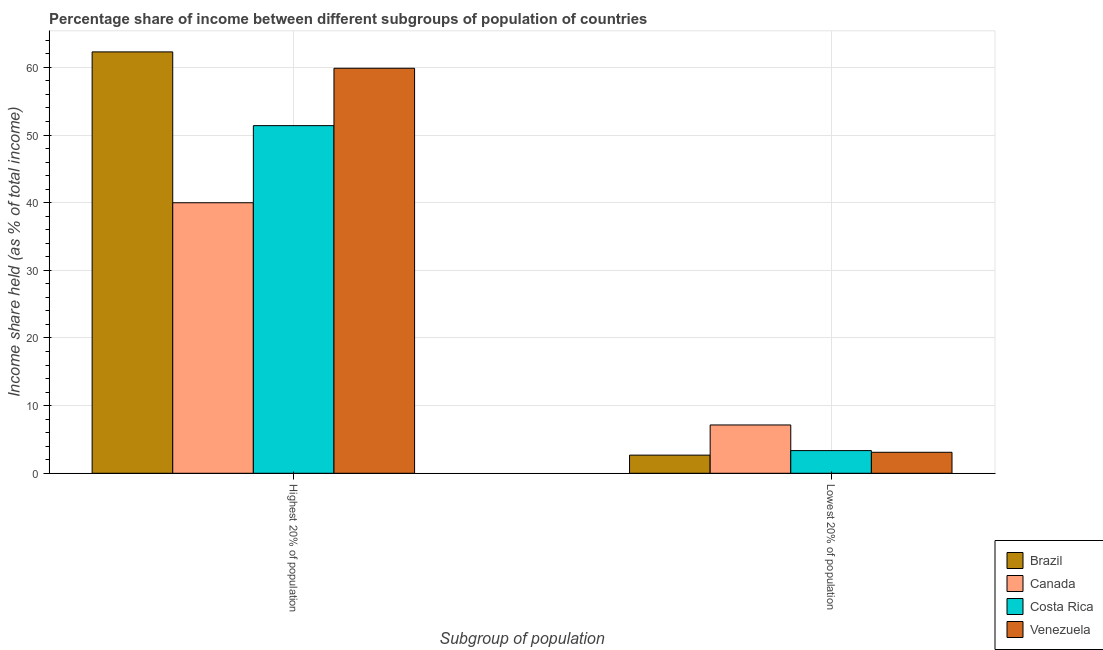How many different coloured bars are there?
Your answer should be very brief. 4. How many groups of bars are there?
Offer a terse response. 2. Are the number of bars per tick equal to the number of legend labels?
Give a very brief answer. Yes. Are the number of bars on each tick of the X-axis equal?
Offer a terse response. Yes. How many bars are there on the 1st tick from the left?
Give a very brief answer. 4. What is the label of the 1st group of bars from the left?
Make the answer very short. Highest 20% of population. What is the income share held by highest 20% of the population in Costa Rica?
Your response must be concise. 51.39. Across all countries, what is the maximum income share held by highest 20% of the population?
Offer a very short reply. 62.29. Across all countries, what is the minimum income share held by lowest 20% of the population?
Give a very brief answer. 2.68. What is the total income share held by lowest 20% of the population in the graph?
Offer a very short reply. 16.27. What is the difference between the income share held by highest 20% of the population in Brazil and that in Canada?
Keep it short and to the point. 22.3. What is the difference between the income share held by highest 20% of the population in Brazil and the income share held by lowest 20% of the population in Canada?
Provide a short and direct response. 55.15. What is the average income share held by lowest 20% of the population per country?
Offer a very short reply. 4.07. What is the difference between the income share held by lowest 20% of the population and income share held by highest 20% of the population in Venezuela?
Keep it short and to the point. -56.77. What is the ratio of the income share held by highest 20% of the population in Canada to that in Costa Rica?
Your response must be concise. 0.78. Is the income share held by lowest 20% of the population in Canada less than that in Venezuela?
Make the answer very short. No. In how many countries, is the income share held by highest 20% of the population greater than the average income share held by highest 20% of the population taken over all countries?
Keep it short and to the point. 2. What does the 1st bar from the left in Highest 20% of population represents?
Your answer should be compact. Brazil. What does the 3rd bar from the right in Highest 20% of population represents?
Ensure brevity in your answer.  Canada. Are the values on the major ticks of Y-axis written in scientific E-notation?
Your answer should be compact. No. Does the graph contain any zero values?
Keep it short and to the point. No. How many legend labels are there?
Provide a succinct answer. 4. What is the title of the graph?
Your response must be concise. Percentage share of income between different subgroups of population of countries. What is the label or title of the X-axis?
Your answer should be very brief. Subgroup of population. What is the label or title of the Y-axis?
Your response must be concise. Income share held (as % of total income). What is the Income share held (as % of total income) of Brazil in Highest 20% of population?
Provide a short and direct response. 62.29. What is the Income share held (as % of total income) of Canada in Highest 20% of population?
Provide a short and direct response. 39.99. What is the Income share held (as % of total income) in Costa Rica in Highest 20% of population?
Provide a succinct answer. 51.39. What is the Income share held (as % of total income) in Venezuela in Highest 20% of population?
Make the answer very short. 59.87. What is the Income share held (as % of total income) of Brazil in Lowest 20% of population?
Your answer should be very brief. 2.68. What is the Income share held (as % of total income) in Canada in Lowest 20% of population?
Make the answer very short. 7.14. What is the Income share held (as % of total income) of Costa Rica in Lowest 20% of population?
Ensure brevity in your answer.  3.35. Across all Subgroup of population, what is the maximum Income share held (as % of total income) in Brazil?
Give a very brief answer. 62.29. Across all Subgroup of population, what is the maximum Income share held (as % of total income) of Canada?
Provide a succinct answer. 39.99. Across all Subgroup of population, what is the maximum Income share held (as % of total income) of Costa Rica?
Provide a short and direct response. 51.39. Across all Subgroup of population, what is the maximum Income share held (as % of total income) in Venezuela?
Your answer should be compact. 59.87. Across all Subgroup of population, what is the minimum Income share held (as % of total income) in Brazil?
Provide a succinct answer. 2.68. Across all Subgroup of population, what is the minimum Income share held (as % of total income) of Canada?
Your answer should be very brief. 7.14. Across all Subgroup of population, what is the minimum Income share held (as % of total income) in Costa Rica?
Offer a very short reply. 3.35. What is the total Income share held (as % of total income) in Brazil in the graph?
Ensure brevity in your answer.  64.97. What is the total Income share held (as % of total income) in Canada in the graph?
Make the answer very short. 47.13. What is the total Income share held (as % of total income) of Costa Rica in the graph?
Keep it short and to the point. 54.74. What is the total Income share held (as % of total income) of Venezuela in the graph?
Keep it short and to the point. 62.97. What is the difference between the Income share held (as % of total income) of Brazil in Highest 20% of population and that in Lowest 20% of population?
Offer a very short reply. 59.61. What is the difference between the Income share held (as % of total income) of Canada in Highest 20% of population and that in Lowest 20% of population?
Your answer should be very brief. 32.85. What is the difference between the Income share held (as % of total income) of Costa Rica in Highest 20% of population and that in Lowest 20% of population?
Keep it short and to the point. 48.04. What is the difference between the Income share held (as % of total income) of Venezuela in Highest 20% of population and that in Lowest 20% of population?
Provide a succinct answer. 56.77. What is the difference between the Income share held (as % of total income) in Brazil in Highest 20% of population and the Income share held (as % of total income) in Canada in Lowest 20% of population?
Your answer should be very brief. 55.15. What is the difference between the Income share held (as % of total income) in Brazil in Highest 20% of population and the Income share held (as % of total income) in Costa Rica in Lowest 20% of population?
Your response must be concise. 58.94. What is the difference between the Income share held (as % of total income) of Brazil in Highest 20% of population and the Income share held (as % of total income) of Venezuela in Lowest 20% of population?
Your answer should be compact. 59.19. What is the difference between the Income share held (as % of total income) of Canada in Highest 20% of population and the Income share held (as % of total income) of Costa Rica in Lowest 20% of population?
Give a very brief answer. 36.64. What is the difference between the Income share held (as % of total income) in Canada in Highest 20% of population and the Income share held (as % of total income) in Venezuela in Lowest 20% of population?
Provide a succinct answer. 36.89. What is the difference between the Income share held (as % of total income) in Costa Rica in Highest 20% of population and the Income share held (as % of total income) in Venezuela in Lowest 20% of population?
Offer a terse response. 48.29. What is the average Income share held (as % of total income) in Brazil per Subgroup of population?
Provide a short and direct response. 32.48. What is the average Income share held (as % of total income) in Canada per Subgroup of population?
Ensure brevity in your answer.  23.57. What is the average Income share held (as % of total income) of Costa Rica per Subgroup of population?
Provide a succinct answer. 27.37. What is the average Income share held (as % of total income) in Venezuela per Subgroup of population?
Your answer should be very brief. 31.48. What is the difference between the Income share held (as % of total income) of Brazil and Income share held (as % of total income) of Canada in Highest 20% of population?
Provide a succinct answer. 22.3. What is the difference between the Income share held (as % of total income) of Brazil and Income share held (as % of total income) of Venezuela in Highest 20% of population?
Your answer should be very brief. 2.42. What is the difference between the Income share held (as % of total income) of Canada and Income share held (as % of total income) of Costa Rica in Highest 20% of population?
Offer a very short reply. -11.4. What is the difference between the Income share held (as % of total income) in Canada and Income share held (as % of total income) in Venezuela in Highest 20% of population?
Provide a succinct answer. -19.88. What is the difference between the Income share held (as % of total income) in Costa Rica and Income share held (as % of total income) in Venezuela in Highest 20% of population?
Give a very brief answer. -8.48. What is the difference between the Income share held (as % of total income) in Brazil and Income share held (as % of total income) in Canada in Lowest 20% of population?
Offer a very short reply. -4.46. What is the difference between the Income share held (as % of total income) of Brazil and Income share held (as % of total income) of Costa Rica in Lowest 20% of population?
Give a very brief answer. -0.67. What is the difference between the Income share held (as % of total income) of Brazil and Income share held (as % of total income) of Venezuela in Lowest 20% of population?
Your response must be concise. -0.42. What is the difference between the Income share held (as % of total income) of Canada and Income share held (as % of total income) of Costa Rica in Lowest 20% of population?
Give a very brief answer. 3.79. What is the difference between the Income share held (as % of total income) of Canada and Income share held (as % of total income) of Venezuela in Lowest 20% of population?
Provide a succinct answer. 4.04. What is the difference between the Income share held (as % of total income) of Costa Rica and Income share held (as % of total income) of Venezuela in Lowest 20% of population?
Provide a short and direct response. 0.25. What is the ratio of the Income share held (as % of total income) of Brazil in Highest 20% of population to that in Lowest 20% of population?
Your answer should be very brief. 23.24. What is the ratio of the Income share held (as % of total income) in Canada in Highest 20% of population to that in Lowest 20% of population?
Offer a very short reply. 5.6. What is the ratio of the Income share held (as % of total income) of Costa Rica in Highest 20% of population to that in Lowest 20% of population?
Provide a succinct answer. 15.34. What is the ratio of the Income share held (as % of total income) in Venezuela in Highest 20% of population to that in Lowest 20% of population?
Ensure brevity in your answer.  19.31. What is the difference between the highest and the second highest Income share held (as % of total income) of Brazil?
Offer a terse response. 59.61. What is the difference between the highest and the second highest Income share held (as % of total income) of Canada?
Keep it short and to the point. 32.85. What is the difference between the highest and the second highest Income share held (as % of total income) of Costa Rica?
Ensure brevity in your answer.  48.04. What is the difference between the highest and the second highest Income share held (as % of total income) in Venezuela?
Offer a very short reply. 56.77. What is the difference between the highest and the lowest Income share held (as % of total income) of Brazil?
Ensure brevity in your answer.  59.61. What is the difference between the highest and the lowest Income share held (as % of total income) in Canada?
Offer a terse response. 32.85. What is the difference between the highest and the lowest Income share held (as % of total income) of Costa Rica?
Your answer should be very brief. 48.04. What is the difference between the highest and the lowest Income share held (as % of total income) of Venezuela?
Give a very brief answer. 56.77. 